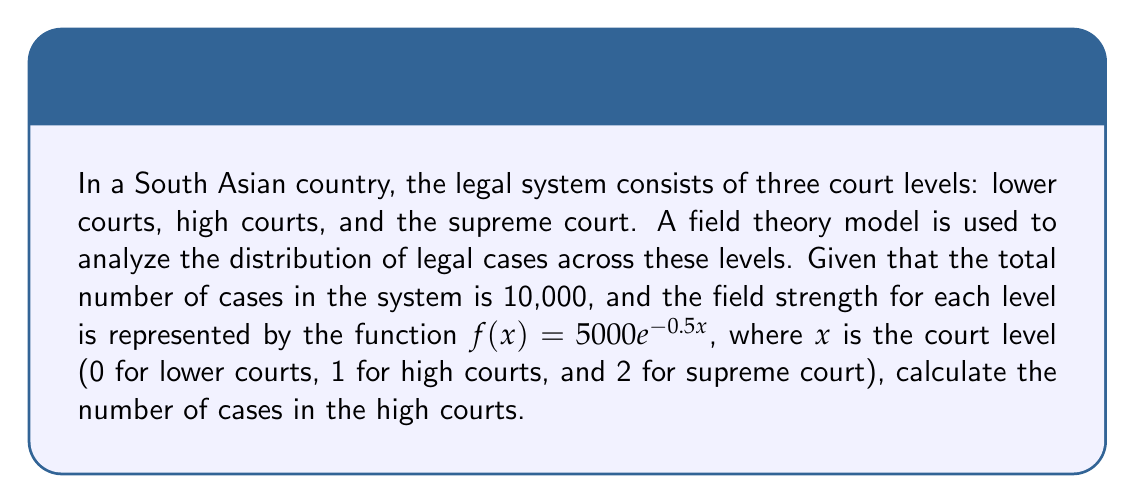Teach me how to tackle this problem. To solve this problem, we'll follow these steps:

1) First, we need to calculate the field strength for each court level:

   Lower courts (x = 0): $f(0) = 5000e^{-0.5(0)} = 5000$
   High courts (x = 1): $f(1) = 5000e^{-0.5(1)} = 5000e^{-0.5}$
   Supreme court (x = 2): $f(2) = 5000e^{-0.5(2)} = 5000e^{-1}$

2) The total field strength is the sum of these values:

   $F_{total} = 5000 + 5000e^{-0.5} + 5000e^{-1}$

3) The proportion of cases in each court level is its field strength divided by the total field strength. For high courts:

   $P_{high} = \frac{5000e^{-0.5}}{5000 + 5000e^{-0.5} + 5000e^{-1}}$

4) To get the number of cases in high courts, we multiply this proportion by the total number of cases:

   $N_{high} = 10000 \cdot \frac{5000e^{-0.5}}{5000 + 5000e^{-0.5} + 5000e^{-1}}$

5) Simplifying:

   $N_{high} = \frac{10000e^{-0.5}}{1 + e^{-0.5} + e^{-1}}$

6) Calculate the numeric value:

   $N_{high} \approx 3033.89$

7) Since we're dealing with whole cases, we round to the nearest integer:

   $N_{high} \approx 3034$
Answer: 3034 cases 